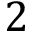<formula> <loc_0><loc_0><loc_500><loc_500>2</formula> 